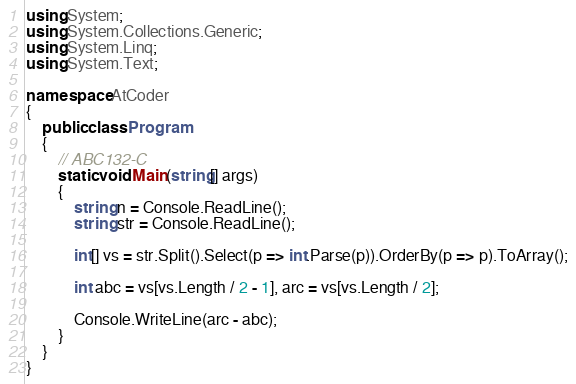Convert code to text. <code><loc_0><loc_0><loc_500><loc_500><_C#_>using System;
using System.Collections.Generic;
using System.Linq;
using System.Text;

namespace AtCoder
{
	public class Program
	{
		// ABC132-C
		static void Main(string[] args)
		{
			string n = Console.ReadLine();
			string str = Console.ReadLine();

			int[] vs = str.Split().Select(p => int.Parse(p)).OrderBy(p => p).ToArray();

			int abc = vs[vs.Length / 2 - 1], arc = vs[vs.Length / 2];

			Console.WriteLine(arc - abc);
		}
	}
}
</code> 